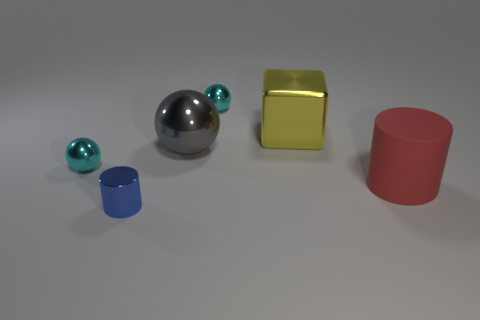Does the red cylinder have the same material as the sphere right of the big gray shiny thing?
Give a very brief answer. No. There is a metallic cube that is the same size as the matte cylinder; what is its color?
Offer a terse response. Yellow. What is the size of the cyan ball that is to the right of the small object that is in front of the big red matte object?
Your answer should be very brief. Small. There is a shiny cylinder; does it have the same color as the small metallic sphere in front of the large yellow cube?
Your answer should be compact. No. Are there fewer cylinders that are to the right of the large matte thing than cylinders?
Your answer should be very brief. Yes. Does the tiny cyan thing in front of the yellow cube have the same shape as the blue shiny object?
Provide a short and direct response. No. Are there more small blue objects in front of the tiny blue cylinder than big metal things?
Offer a very short reply. No. What material is the object that is to the right of the big metallic ball and to the left of the yellow metallic cube?
Ensure brevity in your answer.  Metal. Is there anything else that is the same shape as the large red thing?
Provide a succinct answer. Yes. What number of metal things are in front of the red rubber object and behind the tiny blue cylinder?
Your answer should be compact. 0. 